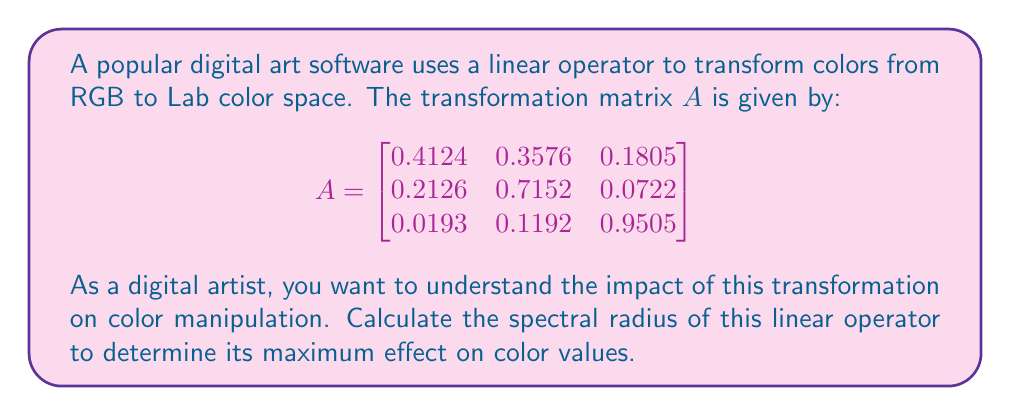Could you help me with this problem? To find the spectral radius of the linear operator, we need to follow these steps:

1) The spectral radius $\rho(A)$ is defined as the maximum of the absolute values of the eigenvalues of $A$.

2) To find the eigenvalues, we need to solve the characteristic equation:
   $\det(A - \lambda I) = 0$

3) Expanding the determinant:
   $$\begin{vmatrix}
   0.4124 - \lambda & 0.3576 & 0.1805 \\
   0.2126 & 0.7152 - \lambda & 0.0722 \\
   0.0193 & 0.1192 & 0.9505 - \lambda
   \end{vmatrix} = 0$$

4) This gives us the characteristic polynomial:
   $-\lambda^3 + 2.0781\lambda^2 - 1.0807\lambda + 0.0026 = 0$

5) Solving this cubic equation (using a computer algebra system or numerical methods) gives us the eigenvalues:
   $\lambda_1 \approx 1.0000$
   $\lambda_2 \approx 0.9998$
   $\lambda_3 \approx 0.0783$

6) Taking the absolute values:
   $|\lambda_1| \approx 1.0000$
   $|\lambda_2| \approx 0.9998$
   $|\lambda_3| \approx 0.0783$

7) The spectral radius is the maximum of these values:
   $\rho(A) = \max\{|\lambda_1|, |\lambda_2|, |\lambda_3|\} \approx 1.0000$
Answer: The spectral radius of the linear operator is approximately 1.0000. 